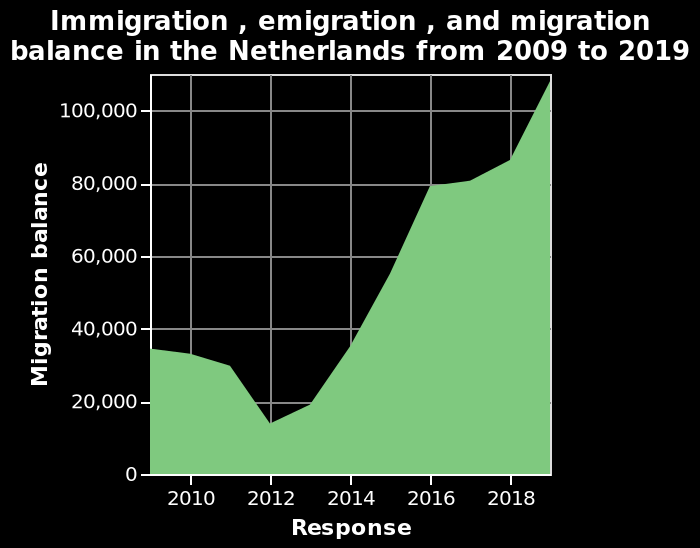<image>
What is the type of plot used to represent immigration, emigration, and migration balance in the Netherlands?  An area plot is used to represent immigration, emigration, and migration balance in the Netherlands. In which year did immigration reach its highest point during the given period?  Immigration reached its highest point in 2019 with 109,000 immigrants. 